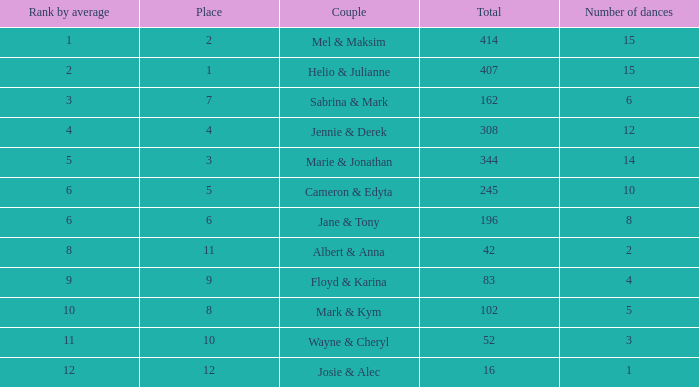What is the smallest place number when the total is 16 and average is less than 16? None. 